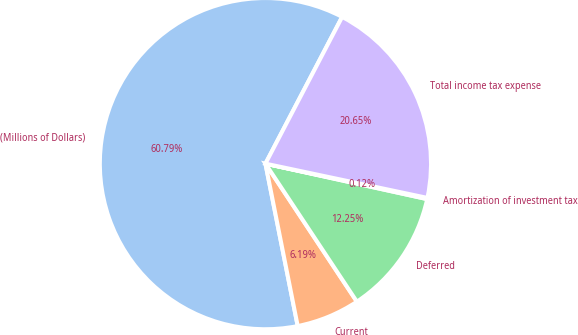Convert chart to OTSL. <chart><loc_0><loc_0><loc_500><loc_500><pie_chart><fcel>(Millions of Dollars)<fcel>Current<fcel>Deferred<fcel>Amortization of investment tax<fcel>Total income tax expense<nl><fcel>60.79%<fcel>6.19%<fcel>12.25%<fcel>0.12%<fcel>20.65%<nl></chart> 